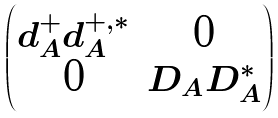Convert formula to latex. <formula><loc_0><loc_0><loc_500><loc_500>\begin{pmatrix} d _ { A } ^ { + } d _ { A } ^ { + , * } & 0 \\ 0 & D _ { A } D _ { A } ^ { * } \end{pmatrix}</formula> 